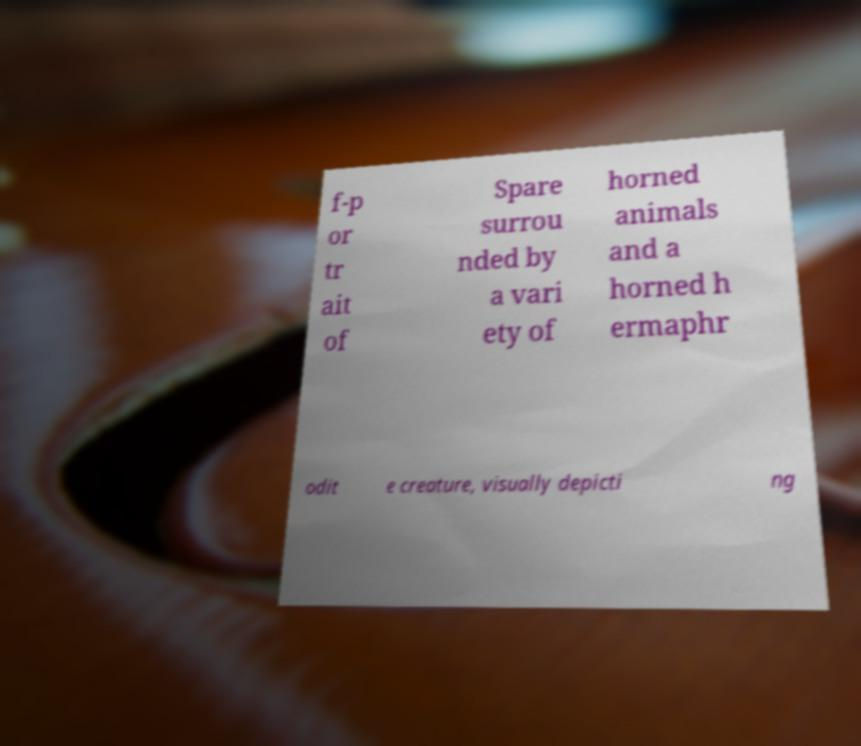For documentation purposes, I need the text within this image transcribed. Could you provide that? f-p or tr ait of Spare surrou nded by a vari ety of horned animals and a horned h ermaphr odit e creature, visually depicti ng 